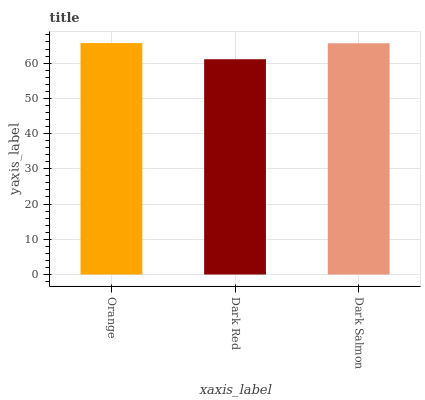Is Dark Red the minimum?
Answer yes or no. Yes. Is Orange the maximum?
Answer yes or no. Yes. Is Dark Salmon the minimum?
Answer yes or no. No. Is Dark Salmon the maximum?
Answer yes or no. No. Is Dark Salmon greater than Dark Red?
Answer yes or no. Yes. Is Dark Red less than Dark Salmon?
Answer yes or no. Yes. Is Dark Red greater than Dark Salmon?
Answer yes or no. No. Is Dark Salmon less than Dark Red?
Answer yes or no. No. Is Dark Salmon the high median?
Answer yes or no. Yes. Is Dark Salmon the low median?
Answer yes or no. Yes. Is Orange the high median?
Answer yes or no. No. Is Dark Red the low median?
Answer yes or no. No. 